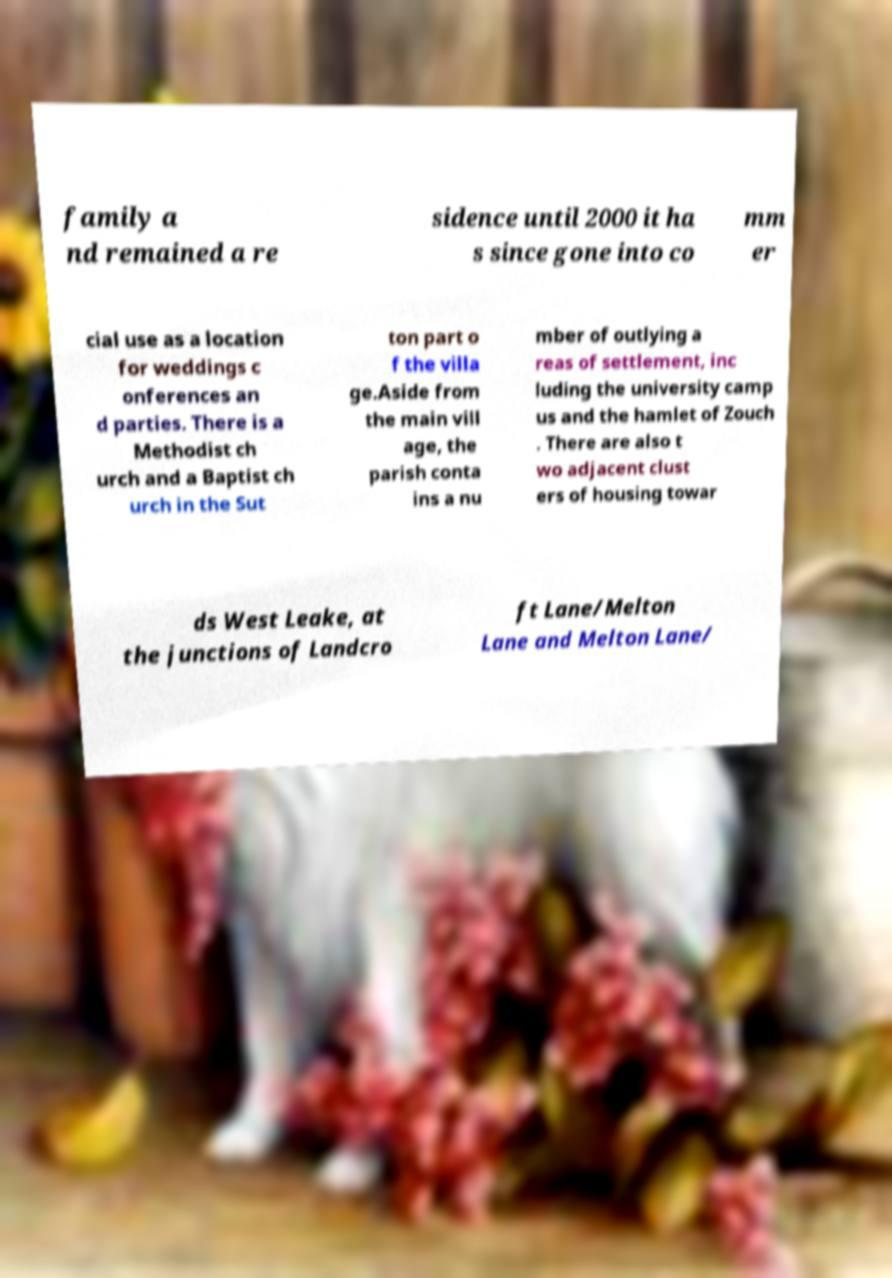What messages or text are displayed in this image? I need them in a readable, typed format. family a nd remained a re sidence until 2000 it ha s since gone into co mm er cial use as a location for weddings c onferences an d parties. There is a Methodist ch urch and a Baptist ch urch in the Sut ton part o f the villa ge.Aside from the main vill age, the parish conta ins a nu mber of outlying a reas of settlement, inc luding the university camp us and the hamlet of Zouch . There are also t wo adjacent clust ers of housing towar ds West Leake, at the junctions of Landcro ft Lane/Melton Lane and Melton Lane/ 